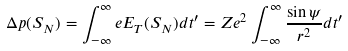<formula> <loc_0><loc_0><loc_500><loc_500>\Delta p ( S _ { N } ) = \int _ { - \infty } ^ { \infty } e E _ { T } ( S _ { N } ) d t ^ { \prime } = Z e ^ { 2 } \int _ { - \infty } ^ { \infty } \frac { \sin \psi } { r ^ { 2 } } d t ^ { \prime }</formula> 